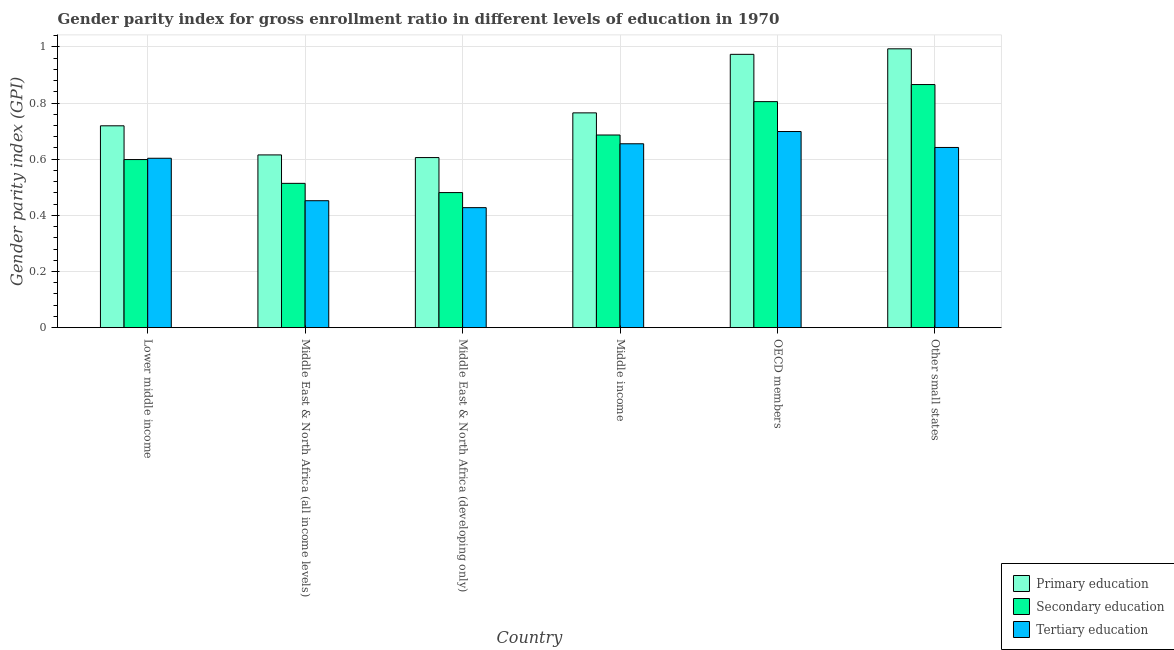Are the number of bars per tick equal to the number of legend labels?
Ensure brevity in your answer.  Yes. Are the number of bars on each tick of the X-axis equal?
Offer a very short reply. Yes. How many bars are there on the 2nd tick from the left?
Your answer should be compact. 3. What is the label of the 3rd group of bars from the left?
Your answer should be very brief. Middle East & North Africa (developing only). In how many cases, is the number of bars for a given country not equal to the number of legend labels?
Your answer should be compact. 0. What is the gender parity index in primary education in Middle income?
Offer a terse response. 0.77. Across all countries, what is the maximum gender parity index in primary education?
Provide a short and direct response. 0.99. Across all countries, what is the minimum gender parity index in primary education?
Keep it short and to the point. 0.61. In which country was the gender parity index in tertiary education minimum?
Your answer should be compact. Middle East & North Africa (developing only). What is the total gender parity index in tertiary education in the graph?
Provide a short and direct response. 3.48. What is the difference between the gender parity index in secondary education in Lower middle income and that in OECD members?
Give a very brief answer. -0.21. What is the difference between the gender parity index in secondary education in OECD members and the gender parity index in primary education in Middle East & North Africa (all income levels)?
Offer a terse response. 0.19. What is the average gender parity index in secondary education per country?
Offer a terse response. 0.66. What is the difference between the gender parity index in primary education and gender parity index in secondary education in Middle East & North Africa (all income levels)?
Keep it short and to the point. 0.1. In how many countries, is the gender parity index in primary education greater than 0.36 ?
Your answer should be compact. 6. What is the ratio of the gender parity index in secondary education in Lower middle income to that in Middle East & North Africa (developing only)?
Keep it short and to the point. 1.24. Is the difference between the gender parity index in secondary education in Middle East & North Africa (developing only) and Middle income greater than the difference between the gender parity index in tertiary education in Middle East & North Africa (developing only) and Middle income?
Provide a short and direct response. Yes. What is the difference between the highest and the second highest gender parity index in tertiary education?
Your answer should be very brief. 0.04. What is the difference between the highest and the lowest gender parity index in tertiary education?
Provide a succinct answer. 0.27. What does the 3rd bar from the right in Middle income represents?
Your response must be concise. Primary education. How many bars are there?
Ensure brevity in your answer.  18. Are all the bars in the graph horizontal?
Offer a very short reply. No. How many countries are there in the graph?
Your answer should be compact. 6. Does the graph contain any zero values?
Ensure brevity in your answer.  No. Does the graph contain grids?
Provide a succinct answer. Yes. Where does the legend appear in the graph?
Keep it short and to the point. Bottom right. What is the title of the graph?
Provide a succinct answer. Gender parity index for gross enrollment ratio in different levels of education in 1970. What is the label or title of the Y-axis?
Offer a very short reply. Gender parity index (GPI). What is the Gender parity index (GPI) in Primary education in Lower middle income?
Provide a succinct answer. 0.72. What is the Gender parity index (GPI) of Secondary education in Lower middle income?
Keep it short and to the point. 0.6. What is the Gender parity index (GPI) of Tertiary education in Lower middle income?
Keep it short and to the point. 0.6. What is the Gender parity index (GPI) of Primary education in Middle East & North Africa (all income levels)?
Provide a succinct answer. 0.62. What is the Gender parity index (GPI) in Secondary education in Middle East & North Africa (all income levels)?
Provide a succinct answer. 0.51. What is the Gender parity index (GPI) in Tertiary education in Middle East & North Africa (all income levels)?
Your response must be concise. 0.45. What is the Gender parity index (GPI) of Primary education in Middle East & North Africa (developing only)?
Your answer should be very brief. 0.61. What is the Gender parity index (GPI) of Secondary education in Middle East & North Africa (developing only)?
Provide a short and direct response. 0.48. What is the Gender parity index (GPI) of Tertiary education in Middle East & North Africa (developing only)?
Keep it short and to the point. 0.43. What is the Gender parity index (GPI) of Primary education in Middle income?
Provide a succinct answer. 0.77. What is the Gender parity index (GPI) of Secondary education in Middle income?
Your answer should be compact. 0.69. What is the Gender parity index (GPI) of Tertiary education in Middle income?
Your response must be concise. 0.65. What is the Gender parity index (GPI) in Primary education in OECD members?
Give a very brief answer. 0.97. What is the Gender parity index (GPI) of Secondary education in OECD members?
Provide a short and direct response. 0.81. What is the Gender parity index (GPI) in Tertiary education in OECD members?
Give a very brief answer. 0.7. What is the Gender parity index (GPI) of Primary education in Other small states?
Provide a short and direct response. 0.99. What is the Gender parity index (GPI) in Secondary education in Other small states?
Provide a succinct answer. 0.87. What is the Gender parity index (GPI) of Tertiary education in Other small states?
Your answer should be very brief. 0.64. Across all countries, what is the maximum Gender parity index (GPI) in Primary education?
Offer a terse response. 0.99. Across all countries, what is the maximum Gender parity index (GPI) in Secondary education?
Provide a short and direct response. 0.87. Across all countries, what is the maximum Gender parity index (GPI) of Tertiary education?
Provide a short and direct response. 0.7. Across all countries, what is the minimum Gender parity index (GPI) in Primary education?
Offer a terse response. 0.61. Across all countries, what is the minimum Gender parity index (GPI) of Secondary education?
Ensure brevity in your answer.  0.48. Across all countries, what is the minimum Gender parity index (GPI) in Tertiary education?
Give a very brief answer. 0.43. What is the total Gender parity index (GPI) in Primary education in the graph?
Ensure brevity in your answer.  4.67. What is the total Gender parity index (GPI) in Secondary education in the graph?
Keep it short and to the point. 3.95. What is the total Gender parity index (GPI) of Tertiary education in the graph?
Your answer should be compact. 3.48. What is the difference between the Gender parity index (GPI) in Primary education in Lower middle income and that in Middle East & North Africa (all income levels)?
Give a very brief answer. 0.1. What is the difference between the Gender parity index (GPI) of Secondary education in Lower middle income and that in Middle East & North Africa (all income levels)?
Ensure brevity in your answer.  0.08. What is the difference between the Gender parity index (GPI) of Tertiary education in Lower middle income and that in Middle East & North Africa (all income levels)?
Provide a succinct answer. 0.15. What is the difference between the Gender parity index (GPI) in Primary education in Lower middle income and that in Middle East & North Africa (developing only)?
Give a very brief answer. 0.11. What is the difference between the Gender parity index (GPI) of Secondary education in Lower middle income and that in Middle East & North Africa (developing only)?
Ensure brevity in your answer.  0.12. What is the difference between the Gender parity index (GPI) of Tertiary education in Lower middle income and that in Middle East & North Africa (developing only)?
Ensure brevity in your answer.  0.18. What is the difference between the Gender parity index (GPI) in Primary education in Lower middle income and that in Middle income?
Your answer should be compact. -0.05. What is the difference between the Gender parity index (GPI) of Secondary education in Lower middle income and that in Middle income?
Offer a very short reply. -0.09. What is the difference between the Gender parity index (GPI) of Tertiary education in Lower middle income and that in Middle income?
Offer a very short reply. -0.05. What is the difference between the Gender parity index (GPI) of Primary education in Lower middle income and that in OECD members?
Provide a short and direct response. -0.25. What is the difference between the Gender parity index (GPI) in Secondary education in Lower middle income and that in OECD members?
Make the answer very short. -0.21. What is the difference between the Gender parity index (GPI) of Tertiary education in Lower middle income and that in OECD members?
Provide a succinct answer. -0.1. What is the difference between the Gender parity index (GPI) in Primary education in Lower middle income and that in Other small states?
Your response must be concise. -0.27. What is the difference between the Gender parity index (GPI) of Secondary education in Lower middle income and that in Other small states?
Your answer should be very brief. -0.27. What is the difference between the Gender parity index (GPI) of Tertiary education in Lower middle income and that in Other small states?
Give a very brief answer. -0.04. What is the difference between the Gender parity index (GPI) of Primary education in Middle East & North Africa (all income levels) and that in Middle East & North Africa (developing only)?
Your response must be concise. 0.01. What is the difference between the Gender parity index (GPI) in Secondary education in Middle East & North Africa (all income levels) and that in Middle East & North Africa (developing only)?
Offer a terse response. 0.03. What is the difference between the Gender parity index (GPI) of Tertiary education in Middle East & North Africa (all income levels) and that in Middle East & North Africa (developing only)?
Your response must be concise. 0.02. What is the difference between the Gender parity index (GPI) of Primary education in Middle East & North Africa (all income levels) and that in Middle income?
Offer a terse response. -0.15. What is the difference between the Gender parity index (GPI) of Secondary education in Middle East & North Africa (all income levels) and that in Middle income?
Keep it short and to the point. -0.17. What is the difference between the Gender parity index (GPI) of Tertiary education in Middle East & North Africa (all income levels) and that in Middle income?
Give a very brief answer. -0.2. What is the difference between the Gender parity index (GPI) in Primary education in Middle East & North Africa (all income levels) and that in OECD members?
Your answer should be very brief. -0.36. What is the difference between the Gender parity index (GPI) in Secondary education in Middle East & North Africa (all income levels) and that in OECD members?
Offer a terse response. -0.29. What is the difference between the Gender parity index (GPI) of Tertiary education in Middle East & North Africa (all income levels) and that in OECD members?
Make the answer very short. -0.25. What is the difference between the Gender parity index (GPI) in Primary education in Middle East & North Africa (all income levels) and that in Other small states?
Ensure brevity in your answer.  -0.38. What is the difference between the Gender parity index (GPI) of Secondary education in Middle East & North Africa (all income levels) and that in Other small states?
Your answer should be compact. -0.35. What is the difference between the Gender parity index (GPI) in Tertiary education in Middle East & North Africa (all income levels) and that in Other small states?
Make the answer very short. -0.19. What is the difference between the Gender parity index (GPI) in Primary education in Middle East & North Africa (developing only) and that in Middle income?
Keep it short and to the point. -0.16. What is the difference between the Gender parity index (GPI) in Secondary education in Middle East & North Africa (developing only) and that in Middle income?
Provide a short and direct response. -0.21. What is the difference between the Gender parity index (GPI) of Tertiary education in Middle East & North Africa (developing only) and that in Middle income?
Your answer should be very brief. -0.23. What is the difference between the Gender parity index (GPI) of Primary education in Middle East & North Africa (developing only) and that in OECD members?
Provide a short and direct response. -0.37. What is the difference between the Gender parity index (GPI) of Secondary education in Middle East & North Africa (developing only) and that in OECD members?
Keep it short and to the point. -0.32. What is the difference between the Gender parity index (GPI) of Tertiary education in Middle East & North Africa (developing only) and that in OECD members?
Make the answer very short. -0.27. What is the difference between the Gender parity index (GPI) of Primary education in Middle East & North Africa (developing only) and that in Other small states?
Your answer should be compact. -0.39. What is the difference between the Gender parity index (GPI) in Secondary education in Middle East & North Africa (developing only) and that in Other small states?
Provide a succinct answer. -0.38. What is the difference between the Gender parity index (GPI) of Tertiary education in Middle East & North Africa (developing only) and that in Other small states?
Your answer should be very brief. -0.21. What is the difference between the Gender parity index (GPI) of Primary education in Middle income and that in OECD members?
Offer a very short reply. -0.21. What is the difference between the Gender parity index (GPI) in Secondary education in Middle income and that in OECD members?
Your answer should be very brief. -0.12. What is the difference between the Gender parity index (GPI) of Tertiary education in Middle income and that in OECD members?
Your response must be concise. -0.04. What is the difference between the Gender parity index (GPI) in Primary education in Middle income and that in Other small states?
Keep it short and to the point. -0.23. What is the difference between the Gender parity index (GPI) in Secondary education in Middle income and that in Other small states?
Your response must be concise. -0.18. What is the difference between the Gender parity index (GPI) in Tertiary education in Middle income and that in Other small states?
Your response must be concise. 0.01. What is the difference between the Gender parity index (GPI) of Primary education in OECD members and that in Other small states?
Your answer should be compact. -0.02. What is the difference between the Gender parity index (GPI) in Secondary education in OECD members and that in Other small states?
Give a very brief answer. -0.06. What is the difference between the Gender parity index (GPI) in Tertiary education in OECD members and that in Other small states?
Ensure brevity in your answer.  0.06. What is the difference between the Gender parity index (GPI) of Primary education in Lower middle income and the Gender parity index (GPI) of Secondary education in Middle East & North Africa (all income levels)?
Your answer should be very brief. 0.2. What is the difference between the Gender parity index (GPI) of Primary education in Lower middle income and the Gender parity index (GPI) of Tertiary education in Middle East & North Africa (all income levels)?
Your answer should be very brief. 0.27. What is the difference between the Gender parity index (GPI) of Secondary education in Lower middle income and the Gender parity index (GPI) of Tertiary education in Middle East & North Africa (all income levels)?
Provide a succinct answer. 0.15. What is the difference between the Gender parity index (GPI) in Primary education in Lower middle income and the Gender parity index (GPI) in Secondary education in Middle East & North Africa (developing only)?
Ensure brevity in your answer.  0.24. What is the difference between the Gender parity index (GPI) in Primary education in Lower middle income and the Gender parity index (GPI) in Tertiary education in Middle East & North Africa (developing only)?
Your answer should be very brief. 0.29. What is the difference between the Gender parity index (GPI) of Secondary education in Lower middle income and the Gender parity index (GPI) of Tertiary education in Middle East & North Africa (developing only)?
Provide a succinct answer. 0.17. What is the difference between the Gender parity index (GPI) of Primary education in Lower middle income and the Gender parity index (GPI) of Secondary education in Middle income?
Your answer should be very brief. 0.03. What is the difference between the Gender parity index (GPI) in Primary education in Lower middle income and the Gender parity index (GPI) in Tertiary education in Middle income?
Give a very brief answer. 0.06. What is the difference between the Gender parity index (GPI) in Secondary education in Lower middle income and the Gender parity index (GPI) in Tertiary education in Middle income?
Keep it short and to the point. -0.06. What is the difference between the Gender parity index (GPI) in Primary education in Lower middle income and the Gender parity index (GPI) in Secondary education in OECD members?
Your response must be concise. -0.09. What is the difference between the Gender parity index (GPI) in Primary education in Lower middle income and the Gender parity index (GPI) in Tertiary education in OECD members?
Give a very brief answer. 0.02. What is the difference between the Gender parity index (GPI) in Secondary education in Lower middle income and the Gender parity index (GPI) in Tertiary education in OECD members?
Make the answer very short. -0.1. What is the difference between the Gender parity index (GPI) of Primary education in Lower middle income and the Gender parity index (GPI) of Secondary education in Other small states?
Your answer should be compact. -0.15. What is the difference between the Gender parity index (GPI) of Primary education in Lower middle income and the Gender parity index (GPI) of Tertiary education in Other small states?
Ensure brevity in your answer.  0.08. What is the difference between the Gender parity index (GPI) of Secondary education in Lower middle income and the Gender parity index (GPI) of Tertiary education in Other small states?
Keep it short and to the point. -0.04. What is the difference between the Gender parity index (GPI) in Primary education in Middle East & North Africa (all income levels) and the Gender parity index (GPI) in Secondary education in Middle East & North Africa (developing only)?
Your answer should be very brief. 0.13. What is the difference between the Gender parity index (GPI) of Primary education in Middle East & North Africa (all income levels) and the Gender parity index (GPI) of Tertiary education in Middle East & North Africa (developing only)?
Your response must be concise. 0.19. What is the difference between the Gender parity index (GPI) in Secondary education in Middle East & North Africa (all income levels) and the Gender parity index (GPI) in Tertiary education in Middle East & North Africa (developing only)?
Your answer should be compact. 0.09. What is the difference between the Gender parity index (GPI) of Primary education in Middle East & North Africa (all income levels) and the Gender parity index (GPI) of Secondary education in Middle income?
Give a very brief answer. -0.07. What is the difference between the Gender parity index (GPI) in Primary education in Middle East & North Africa (all income levels) and the Gender parity index (GPI) in Tertiary education in Middle income?
Ensure brevity in your answer.  -0.04. What is the difference between the Gender parity index (GPI) in Secondary education in Middle East & North Africa (all income levels) and the Gender parity index (GPI) in Tertiary education in Middle income?
Give a very brief answer. -0.14. What is the difference between the Gender parity index (GPI) of Primary education in Middle East & North Africa (all income levels) and the Gender parity index (GPI) of Secondary education in OECD members?
Ensure brevity in your answer.  -0.19. What is the difference between the Gender parity index (GPI) of Primary education in Middle East & North Africa (all income levels) and the Gender parity index (GPI) of Tertiary education in OECD members?
Provide a short and direct response. -0.08. What is the difference between the Gender parity index (GPI) of Secondary education in Middle East & North Africa (all income levels) and the Gender parity index (GPI) of Tertiary education in OECD members?
Offer a terse response. -0.18. What is the difference between the Gender parity index (GPI) of Primary education in Middle East & North Africa (all income levels) and the Gender parity index (GPI) of Secondary education in Other small states?
Give a very brief answer. -0.25. What is the difference between the Gender parity index (GPI) in Primary education in Middle East & North Africa (all income levels) and the Gender parity index (GPI) in Tertiary education in Other small states?
Offer a very short reply. -0.03. What is the difference between the Gender parity index (GPI) of Secondary education in Middle East & North Africa (all income levels) and the Gender parity index (GPI) of Tertiary education in Other small states?
Keep it short and to the point. -0.13. What is the difference between the Gender parity index (GPI) of Primary education in Middle East & North Africa (developing only) and the Gender parity index (GPI) of Secondary education in Middle income?
Offer a very short reply. -0.08. What is the difference between the Gender parity index (GPI) of Primary education in Middle East & North Africa (developing only) and the Gender parity index (GPI) of Tertiary education in Middle income?
Offer a terse response. -0.05. What is the difference between the Gender parity index (GPI) of Secondary education in Middle East & North Africa (developing only) and the Gender parity index (GPI) of Tertiary education in Middle income?
Offer a very short reply. -0.17. What is the difference between the Gender parity index (GPI) of Primary education in Middle East & North Africa (developing only) and the Gender parity index (GPI) of Secondary education in OECD members?
Make the answer very short. -0.2. What is the difference between the Gender parity index (GPI) in Primary education in Middle East & North Africa (developing only) and the Gender parity index (GPI) in Tertiary education in OECD members?
Your answer should be compact. -0.09. What is the difference between the Gender parity index (GPI) of Secondary education in Middle East & North Africa (developing only) and the Gender parity index (GPI) of Tertiary education in OECD members?
Your response must be concise. -0.22. What is the difference between the Gender parity index (GPI) of Primary education in Middle East & North Africa (developing only) and the Gender parity index (GPI) of Secondary education in Other small states?
Your answer should be compact. -0.26. What is the difference between the Gender parity index (GPI) of Primary education in Middle East & North Africa (developing only) and the Gender parity index (GPI) of Tertiary education in Other small states?
Your response must be concise. -0.04. What is the difference between the Gender parity index (GPI) of Secondary education in Middle East & North Africa (developing only) and the Gender parity index (GPI) of Tertiary education in Other small states?
Offer a terse response. -0.16. What is the difference between the Gender parity index (GPI) of Primary education in Middle income and the Gender parity index (GPI) of Secondary education in OECD members?
Provide a short and direct response. -0.04. What is the difference between the Gender parity index (GPI) in Primary education in Middle income and the Gender parity index (GPI) in Tertiary education in OECD members?
Ensure brevity in your answer.  0.07. What is the difference between the Gender parity index (GPI) in Secondary education in Middle income and the Gender parity index (GPI) in Tertiary education in OECD members?
Your response must be concise. -0.01. What is the difference between the Gender parity index (GPI) of Primary education in Middle income and the Gender parity index (GPI) of Secondary education in Other small states?
Your answer should be very brief. -0.1. What is the difference between the Gender parity index (GPI) of Primary education in Middle income and the Gender parity index (GPI) of Tertiary education in Other small states?
Your answer should be very brief. 0.12. What is the difference between the Gender parity index (GPI) in Secondary education in Middle income and the Gender parity index (GPI) in Tertiary education in Other small states?
Offer a terse response. 0.04. What is the difference between the Gender parity index (GPI) in Primary education in OECD members and the Gender parity index (GPI) in Secondary education in Other small states?
Your answer should be compact. 0.11. What is the difference between the Gender parity index (GPI) in Primary education in OECD members and the Gender parity index (GPI) in Tertiary education in Other small states?
Ensure brevity in your answer.  0.33. What is the difference between the Gender parity index (GPI) in Secondary education in OECD members and the Gender parity index (GPI) in Tertiary education in Other small states?
Ensure brevity in your answer.  0.16. What is the average Gender parity index (GPI) in Primary education per country?
Provide a short and direct response. 0.78. What is the average Gender parity index (GPI) in Secondary education per country?
Your answer should be very brief. 0.66. What is the average Gender parity index (GPI) in Tertiary education per country?
Your answer should be compact. 0.58. What is the difference between the Gender parity index (GPI) of Primary education and Gender parity index (GPI) of Secondary education in Lower middle income?
Offer a terse response. 0.12. What is the difference between the Gender parity index (GPI) of Primary education and Gender parity index (GPI) of Tertiary education in Lower middle income?
Keep it short and to the point. 0.12. What is the difference between the Gender parity index (GPI) of Secondary education and Gender parity index (GPI) of Tertiary education in Lower middle income?
Give a very brief answer. -0. What is the difference between the Gender parity index (GPI) in Primary education and Gender parity index (GPI) in Secondary education in Middle East & North Africa (all income levels)?
Make the answer very short. 0.1. What is the difference between the Gender parity index (GPI) of Primary education and Gender parity index (GPI) of Tertiary education in Middle East & North Africa (all income levels)?
Provide a short and direct response. 0.16. What is the difference between the Gender parity index (GPI) of Secondary education and Gender parity index (GPI) of Tertiary education in Middle East & North Africa (all income levels)?
Keep it short and to the point. 0.06. What is the difference between the Gender parity index (GPI) in Primary education and Gender parity index (GPI) in Secondary education in Middle East & North Africa (developing only)?
Keep it short and to the point. 0.12. What is the difference between the Gender parity index (GPI) in Primary education and Gender parity index (GPI) in Tertiary education in Middle East & North Africa (developing only)?
Your answer should be very brief. 0.18. What is the difference between the Gender parity index (GPI) in Secondary education and Gender parity index (GPI) in Tertiary education in Middle East & North Africa (developing only)?
Keep it short and to the point. 0.05. What is the difference between the Gender parity index (GPI) of Primary education and Gender parity index (GPI) of Secondary education in Middle income?
Your answer should be compact. 0.08. What is the difference between the Gender parity index (GPI) of Primary education and Gender parity index (GPI) of Tertiary education in Middle income?
Provide a short and direct response. 0.11. What is the difference between the Gender parity index (GPI) of Secondary education and Gender parity index (GPI) of Tertiary education in Middle income?
Provide a succinct answer. 0.03. What is the difference between the Gender parity index (GPI) of Primary education and Gender parity index (GPI) of Secondary education in OECD members?
Your answer should be compact. 0.17. What is the difference between the Gender parity index (GPI) in Primary education and Gender parity index (GPI) in Tertiary education in OECD members?
Ensure brevity in your answer.  0.27. What is the difference between the Gender parity index (GPI) of Secondary education and Gender parity index (GPI) of Tertiary education in OECD members?
Make the answer very short. 0.11. What is the difference between the Gender parity index (GPI) in Primary education and Gender parity index (GPI) in Secondary education in Other small states?
Your response must be concise. 0.13. What is the difference between the Gender parity index (GPI) in Primary education and Gender parity index (GPI) in Tertiary education in Other small states?
Keep it short and to the point. 0.35. What is the difference between the Gender parity index (GPI) of Secondary education and Gender parity index (GPI) of Tertiary education in Other small states?
Your answer should be very brief. 0.22. What is the ratio of the Gender parity index (GPI) of Primary education in Lower middle income to that in Middle East & North Africa (all income levels)?
Your response must be concise. 1.17. What is the ratio of the Gender parity index (GPI) in Secondary education in Lower middle income to that in Middle East & North Africa (all income levels)?
Offer a very short reply. 1.16. What is the ratio of the Gender parity index (GPI) of Tertiary education in Lower middle income to that in Middle East & North Africa (all income levels)?
Make the answer very short. 1.33. What is the ratio of the Gender parity index (GPI) of Primary education in Lower middle income to that in Middle East & North Africa (developing only)?
Provide a short and direct response. 1.19. What is the ratio of the Gender parity index (GPI) in Secondary education in Lower middle income to that in Middle East & North Africa (developing only)?
Offer a very short reply. 1.24. What is the ratio of the Gender parity index (GPI) in Tertiary education in Lower middle income to that in Middle East & North Africa (developing only)?
Ensure brevity in your answer.  1.41. What is the ratio of the Gender parity index (GPI) of Primary education in Lower middle income to that in Middle income?
Offer a very short reply. 0.94. What is the ratio of the Gender parity index (GPI) of Secondary education in Lower middle income to that in Middle income?
Your answer should be very brief. 0.87. What is the ratio of the Gender parity index (GPI) of Tertiary education in Lower middle income to that in Middle income?
Offer a terse response. 0.92. What is the ratio of the Gender parity index (GPI) in Primary education in Lower middle income to that in OECD members?
Give a very brief answer. 0.74. What is the ratio of the Gender parity index (GPI) in Secondary education in Lower middle income to that in OECD members?
Keep it short and to the point. 0.74. What is the ratio of the Gender parity index (GPI) in Tertiary education in Lower middle income to that in OECD members?
Keep it short and to the point. 0.86. What is the ratio of the Gender parity index (GPI) of Primary education in Lower middle income to that in Other small states?
Ensure brevity in your answer.  0.72. What is the ratio of the Gender parity index (GPI) in Secondary education in Lower middle income to that in Other small states?
Provide a succinct answer. 0.69. What is the ratio of the Gender parity index (GPI) of Tertiary education in Lower middle income to that in Other small states?
Keep it short and to the point. 0.94. What is the ratio of the Gender parity index (GPI) in Primary education in Middle East & North Africa (all income levels) to that in Middle East & North Africa (developing only)?
Make the answer very short. 1.02. What is the ratio of the Gender parity index (GPI) in Secondary education in Middle East & North Africa (all income levels) to that in Middle East & North Africa (developing only)?
Give a very brief answer. 1.07. What is the ratio of the Gender parity index (GPI) in Tertiary education in Middle East & North Africa (all income levels) to that in Middle East & North Africa (developing only)?
Give a very brief answer. 1.06. What is the ratio of the Gender parity index (GPI) in Primary education in Middle East & North Africa (all income levels) to that in Middle income?
Give a very brief answer. 0.8. What is the ratio of the Gender parity index (GPI) in Secondary education in Middle East & North Africa (all income levels) to that in Middle income?
Offer a very short reply. 0.75. What is the ratio of the Gender parity index (GPI) in Tertiary education in Middle East & North Africa (all income levels) to that in Middle income?
Keep it short and to the point. 0.69. What is the ratio of the Gender parity index (GPI) in Primary education in Middle East & North Africa (all income levels) to that in OECD members?
Offer a very short reply. 0.63. What is the ratio of the Gender parity index (GPI) of Secondary education in Middle East & North Africa (all income levels) to that in OECD members?
Your answer should be very brief. 0.64. What is the ratio of the Gender parity index (GPI) in Tertiary education in Middle East & North Africa (all income levels) to that in OECD members?
Give a very brief answer. 0.65. What is the ratio of the Gender parity index (GPI) of Primary education in Middle East & North Africa (all income levels) to that in Other small states?
Offer a terse response. 0.62. What is the ratio of the Gender parity index (GPI) of Secondary education in Middle East & North Africa (all income levels) to that in Other small states?
Your answer should be compact. 0.59. What is the ratio of the Gender parity index (GPI) of Tertiary education in Middle East & North Africa (all income levels) to that in Other small states?
Offer a terse response. 0.7. What is the ratio of the Gender parity index (GPI) of Primary education in Middle East & North Africa (developing only) to that in Middle income?
Ensure brevity in your answer.  0.79. What is the ratio of the Gender parity index (GPI) in Secondary education in Middle East & North Africa (developing only) to that in Middle income?
Provide a short and direct response. 0.7. What is the ratio of the Gender parity index (GPI) in Tertiary education in Middle East & North Africa (developing only) to that in Middle income?
Keep it short and to the point. 0.65. What is the ratio of the Gender parity index (GPI) in Primary education in Middle East & North Africa (developing only) to that in OECD members?
Provide a short and direct response. 0.62. What is the ratio of the Gender parity index (GPI) in Secondary education in Middle East & North Africa (developing only) to that in OECD members?
Offer a terse response. 0.6. What is the ratio of the Gender parity index (GPI) of Tertiary education in Middle East & North Africa (developing only) to that in OECD members?
Provide a succinct answer. 0.61. What is the ratio of the Gender parity index (GPI) of Primary education in Middle East & North Africa (developing only) to that in Other small states?
Your answer should be very brief. 0.61. What is the ratio of the Gender parity index (GPI) in Secondary education in Middle East & North Africa (developing only) to that in Other small states?
Provide a succinct answer. 0.56. What is the ratio of the Gender parity index (GPI) of Tertiary education in Middle East & North Africa (developing only) to that in Other small states?
Your response must be concise. 0.67. What is the ratio of the Gender parity index (GPI) of Primary education in Middle income to that in OECD members?
Make the answer very short. 0.79. What is the ratio of the Gender parity index (GPI) in Secondary education in Middle income to that in OECD members?
Your response must be concise. 0.85. What is the ratio of the Gender parity index (GPI) in Tertiary education in Middle income to that in OECD members?
Give a very brief answer. 0.94. What is the ratio of the Gender parity index (GPI) in Primary education in Middle income to that in Other small states?
Offer a terse response. 0.77. What is the ratio of the Gender parity index (GPI) of Secondary education in Middle income to that in Other small states?
Provide a succinct answer. 0.79. What is the ratio of the Gender parity index (GPI) of Tertiary education in Middle income to that in Other small states?
Give a very brief answer. 1.02. What is the ratio of the Gender parity index (GPI) of Primary education in OECD members to that in Other small states?
Provide a short and direct response. 0.98. What is the ratio of the Gender parity index (GPI) of Secondary education in OECD members to that in Other small states?
Provide a succinct answer. 0.93. What is the ratio of the Gender parity index (GPI) of Tertiary education in OECD members to that in Other small states?
Ensure brevity in your answer.  1.09. What is the difference between the highest and the second highest Gender parity index (GPI) of Primary education?
Give a very brief answer. 0.02. What is the difference between the highest and the second highest Gender parity index (GPI) of Secondary education?
Offer a very short reply. 0.06. What is the difference between the highest and the second highest Gender parity index (GPI) of Tertiary education?
Offer a terse response. 0.04. What is the difference between the highest and the lowest Gender parity index (GPI) in Primary education?
Provide a succinct answer. 0.39. What is the difference between the highest and the lowest Gender parity index (GPI) of Secondary education?
Your response must be concise. 0.38. What is the difference between the highest and the lowest Gender parity index (GPI) in Tertiary education?
Ensure brevity in your answer.  0.27. 